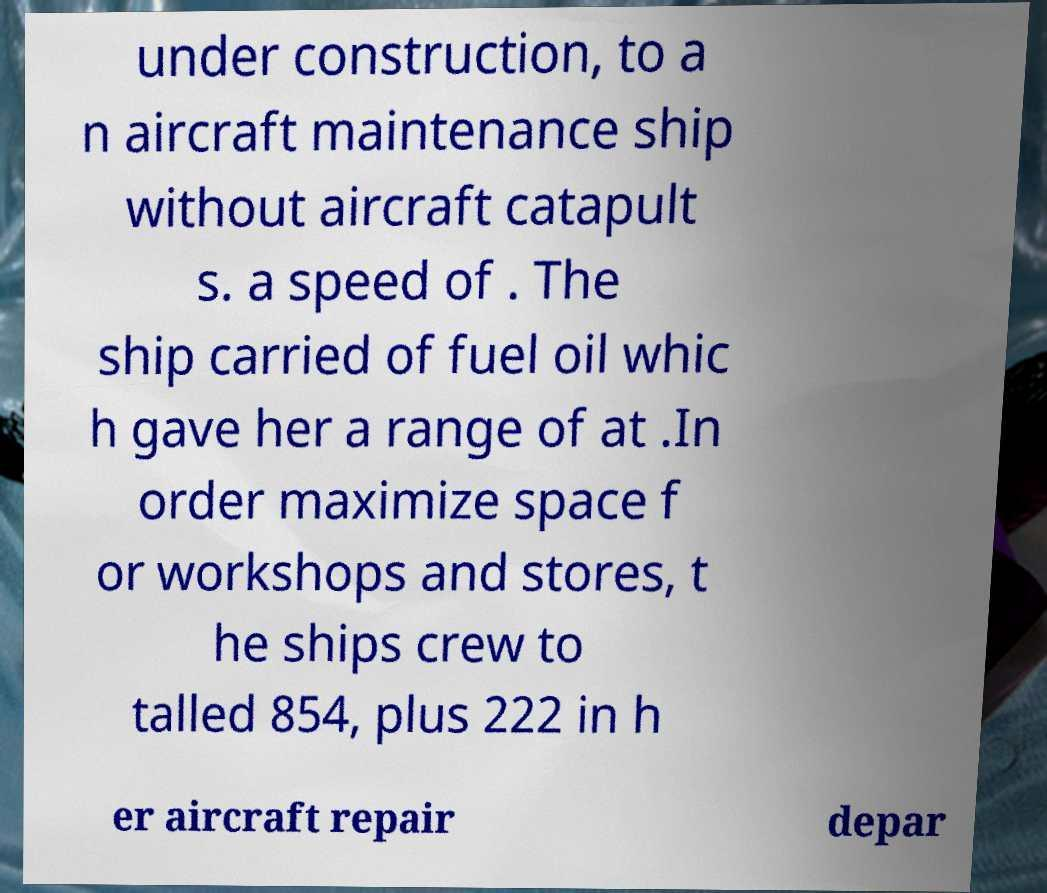I need the written content from this picture converted into text. Can you do that? under construction, to a n aircraft maintenance ship without aircraft catapult s. a speed of . The ship carried of fuel oil whic h gave her a range of at .In order maximize space f or workshops and stores, t he ships crew to talled 854, plus 222 in h er aircraft repair depar 